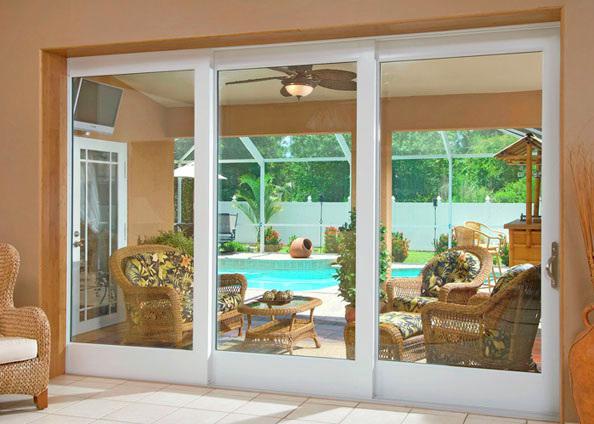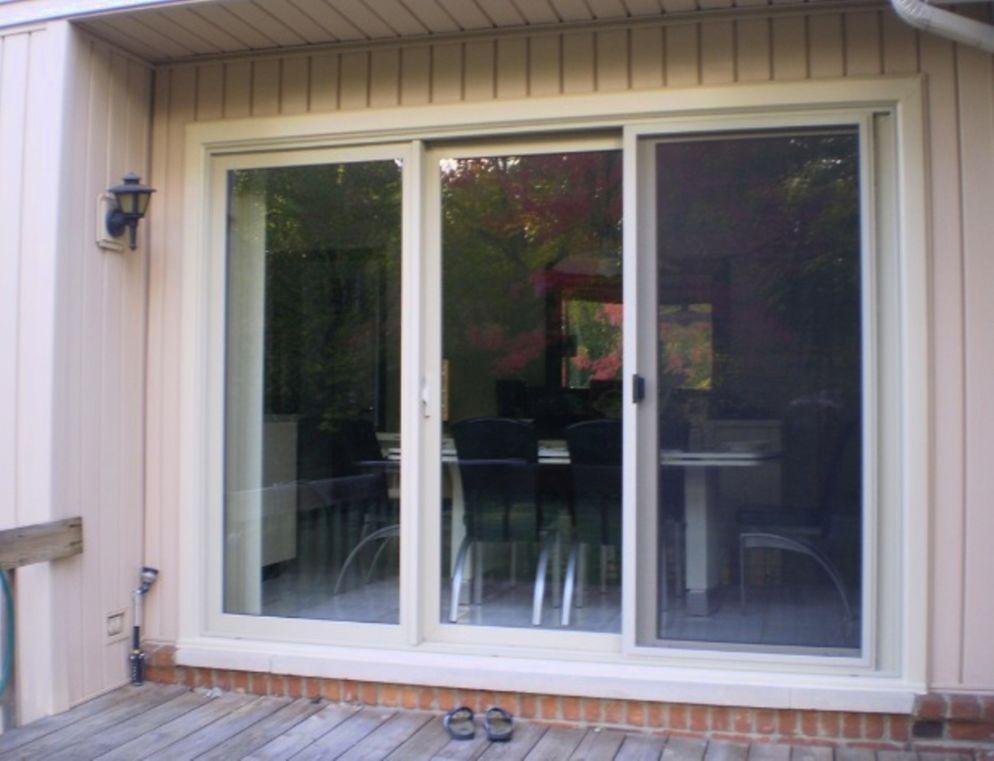The first image is the image on the left, the second image is the image on the right. Analyze the images presented: Is the assertion "Right and left images show the same sliding glass door in the same setting." valid? Answer yes or no. No. The first image is the image on the left, the second image is the image on the right. Considering the images on both sides, is "The frame in each image is white." valid? Answer yes or no. Yes. 